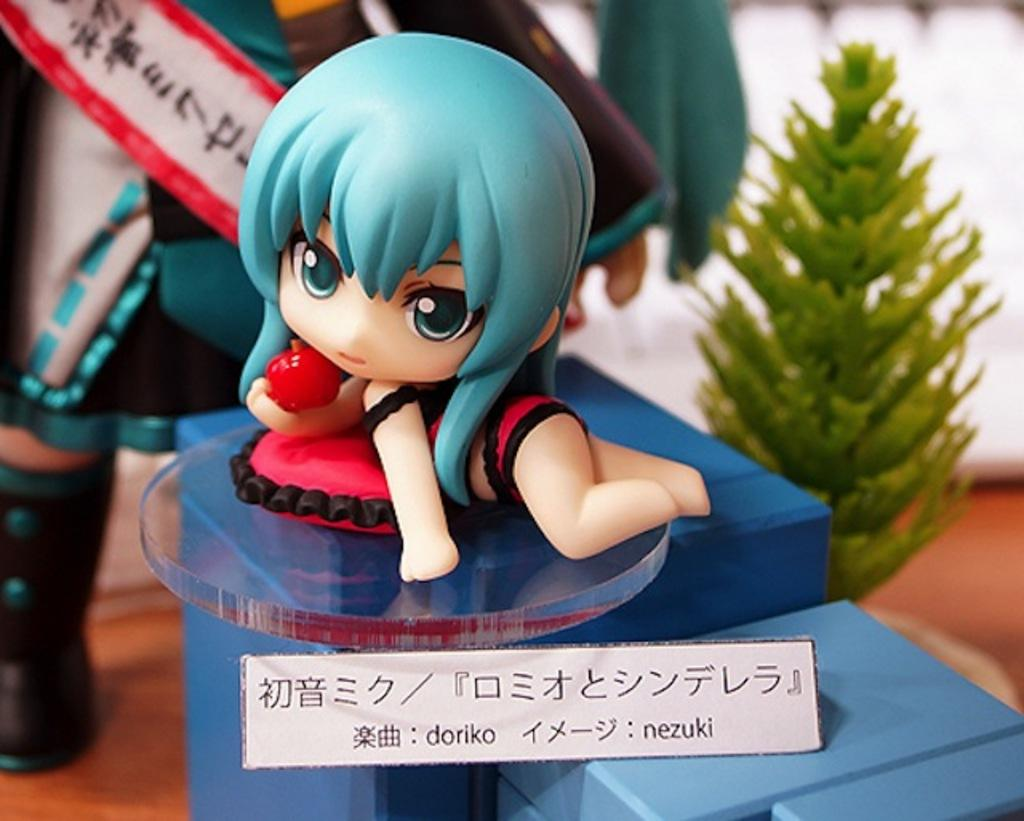What objects are on the blue color box in the image? There are toys on a blue color box in the image. Is there anything attached to the box? Yes, there is a paper attached to the box. What can be found on the paper? There is text on the paper. What can be seen on the right side of the image? There is a plant on the right side of the image. What type of silk is being used to make the toys in the image? There is no mention of silk or any material used to make the toys in the image. The toys are simply described as being on a blue color box. 